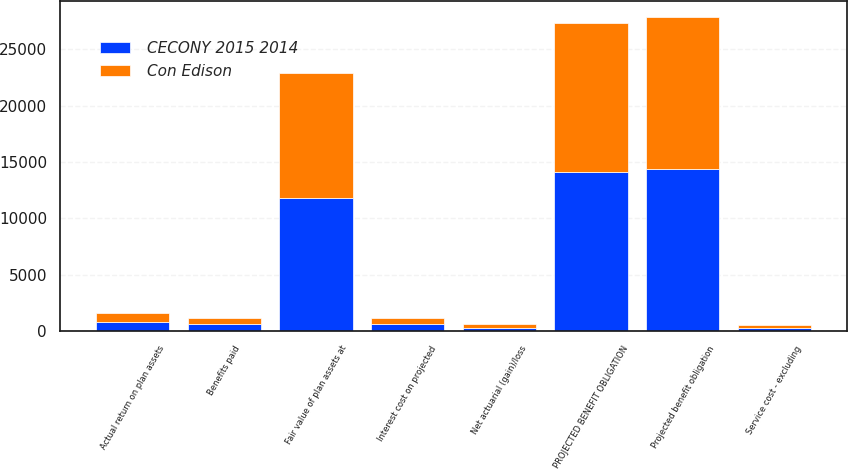<chart> <loc_0><loc_0><loc_500><loc_500><stacked_bar_chart><ecel><fcel>Projected benefit obligation<fcel>Service cost - excluding<fcel>Interest cost on projected<fcel>Net actuarial (gain)/loss<fcel>Benefits paid<fcel>PROJECTED BENEFIT OBLIGATION<fcel>Fair value of plan assets at<fcel>Actual return on plan assets<nl><fcel>CECONY 2015 2014<fcel>14377<fcel>271<fcel>596<fcel>302<fcel>591<fcel>14095<fcel>11759<fcel>829<nl><fcel>Con Edison<fcel>13482<fcel>254<fcel>559<fcel>282<fcel>551<fcel>13203<fcel>11141<fcel>787<nl></chart> 